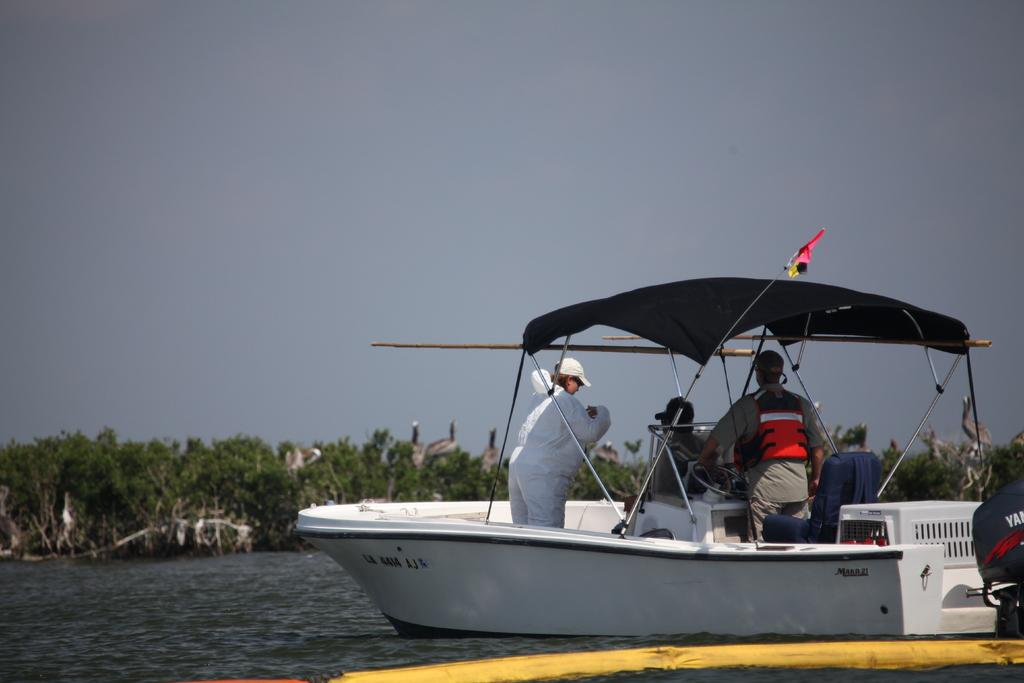What is the main subject of the image? The main subject of the image is people in a boat. What can be seen at the bottom of the image? There is water visible at the bottom of the image. What type of natural environment is visible in the background of the image? There are trees and the sky visible in the background of the image. What type of insurance policy is being discussed by the people in the boat? There is no indication in the image that the people in the boat are discussing any insurance policies. 